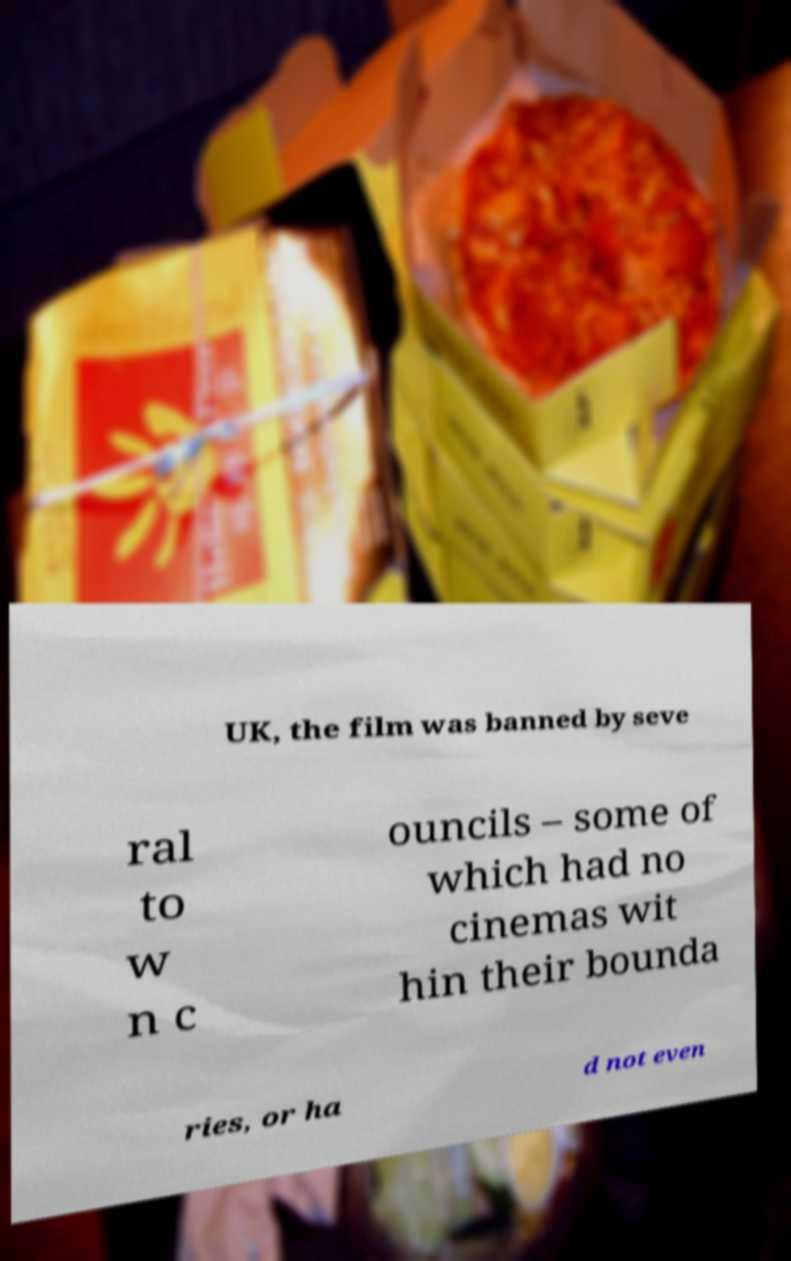Please identify and transcribe the text found in this image. UK, the film was banned by seve ral to w n c ouncils – some of which had no cinemas wit hin their bounda ries, or ha d not even 